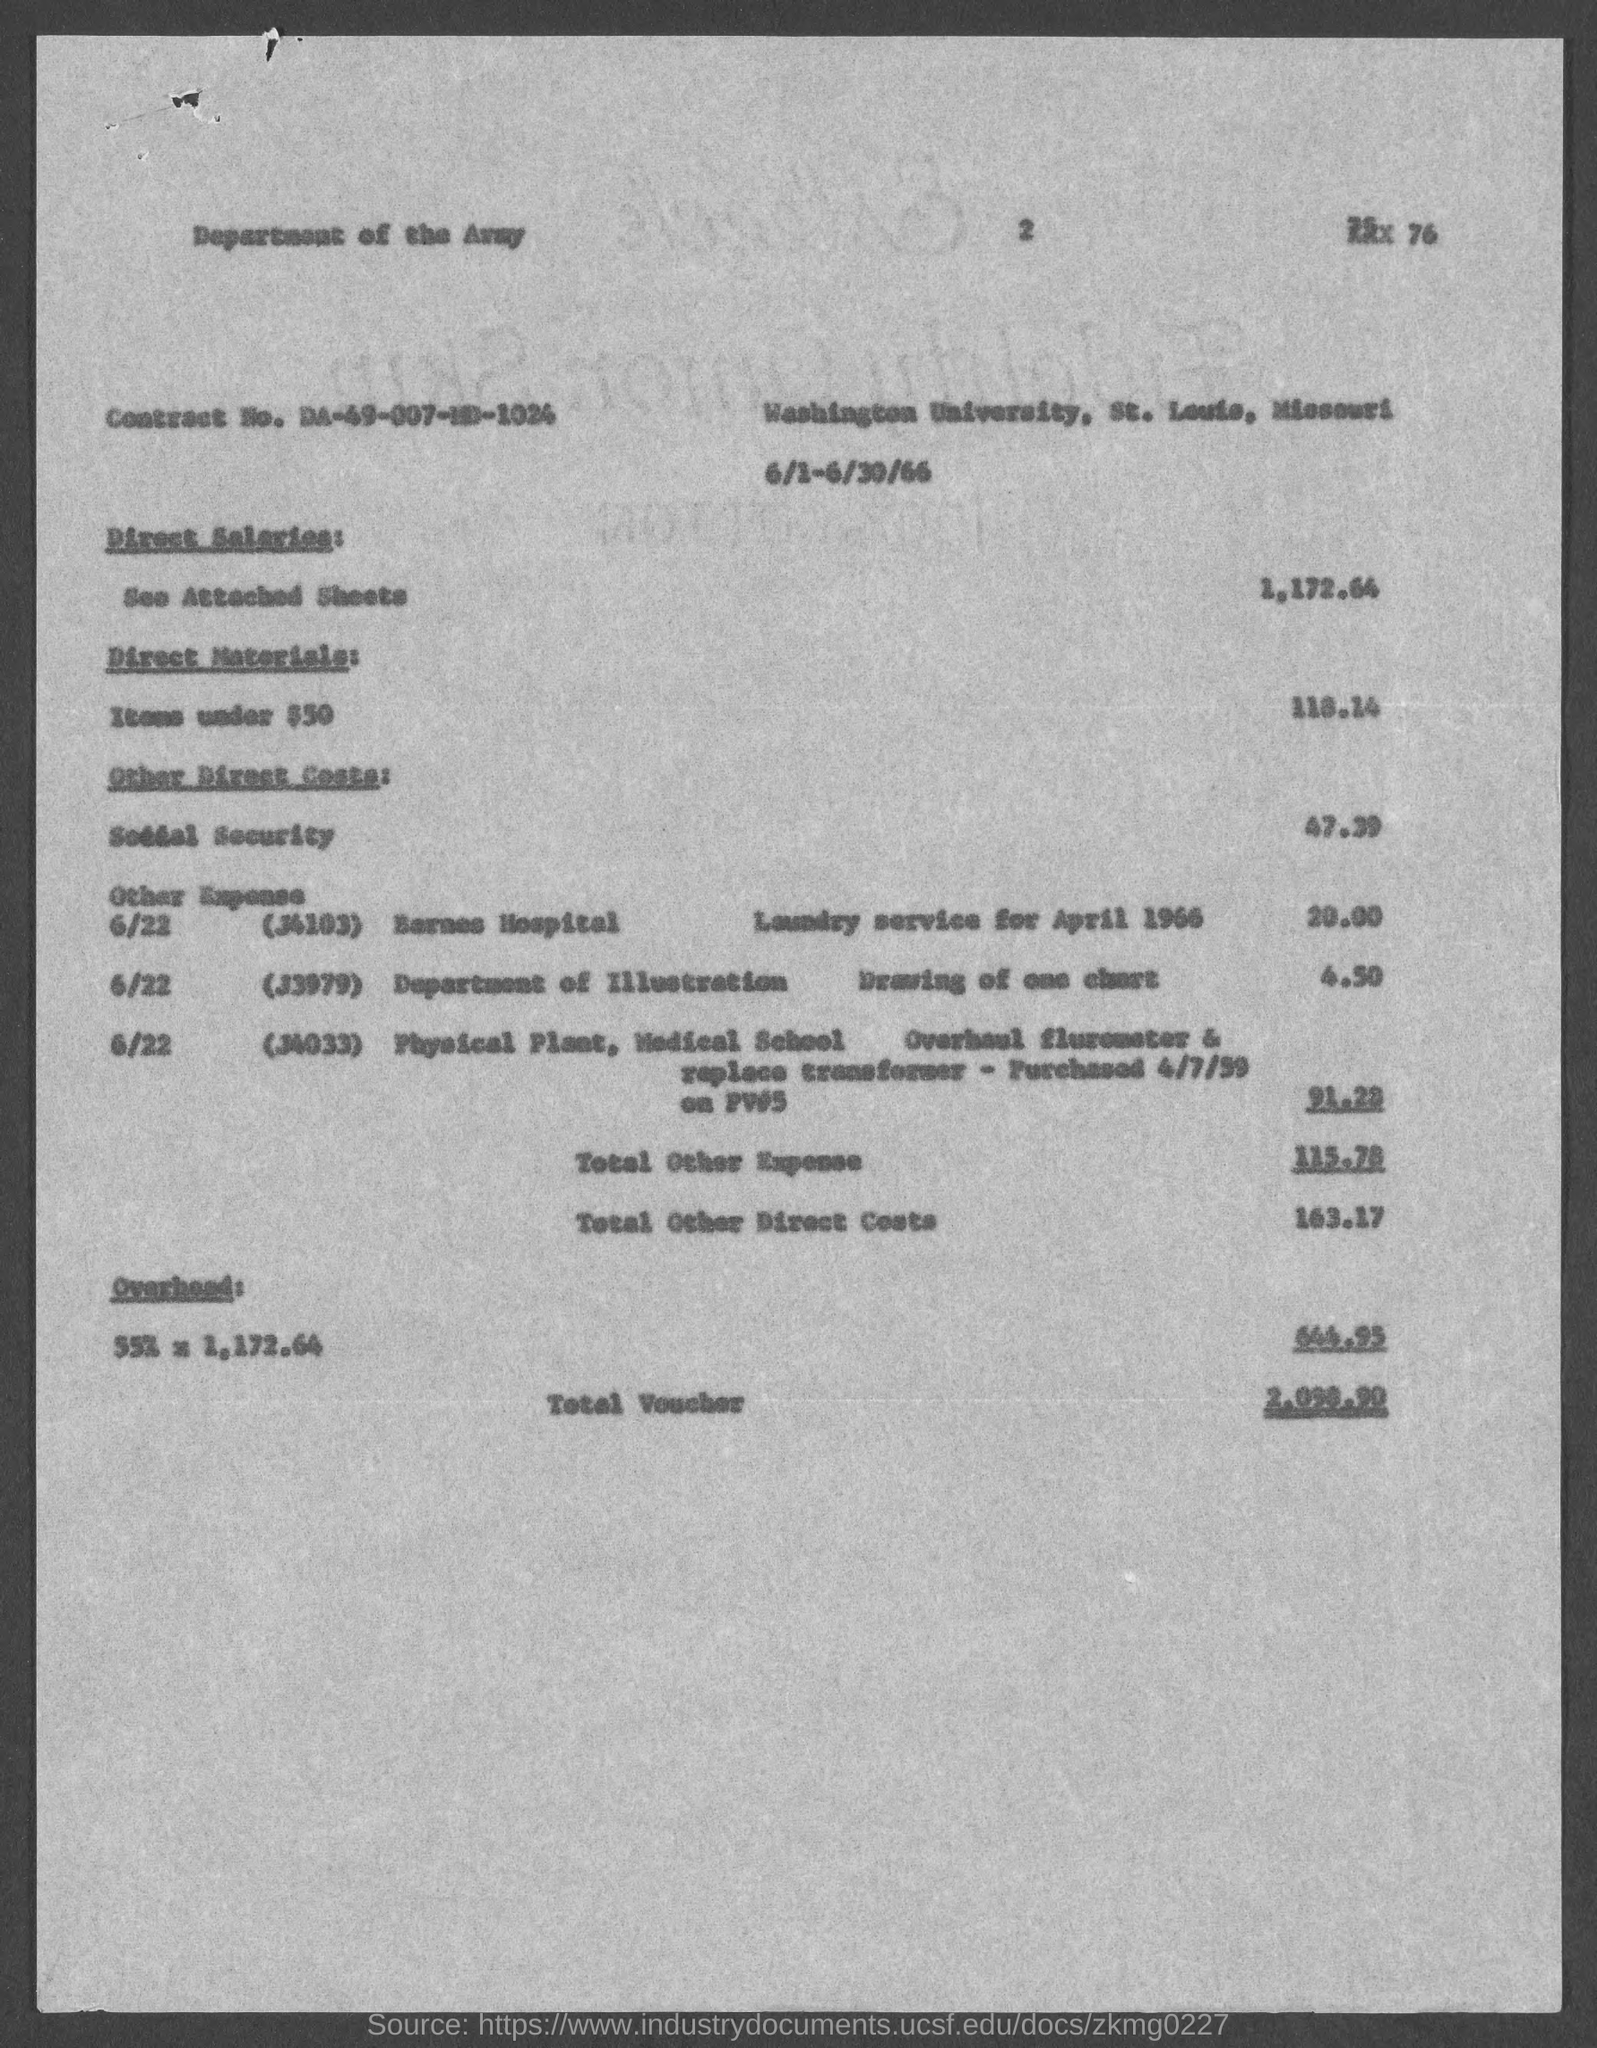Draw attention to some important aspects in this diagram. The overhead cost, as stated in the voucher, is 644.95... The direct materials cost for the items under $50 listed in the voucher is $118.14. The total of other direct costs mentioned in the voucher is 163.17. The direct salaries cost mentioned in the voucher is 1,172.64. The voucher contains the Contract No. DA-49-007-MD-1024. 